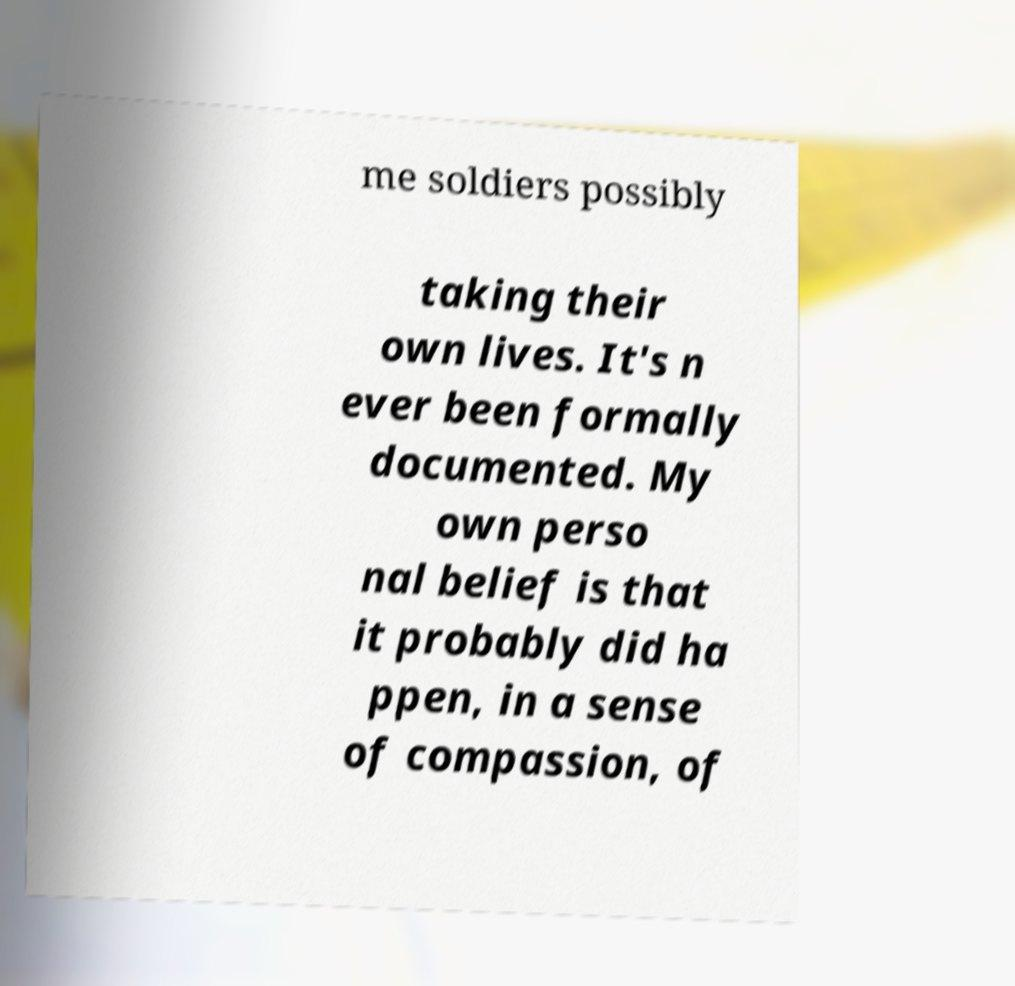Please identify and transcribe the text found in this image. me soldiers possibly taking their own lives. It's n ever been formally documented. My own perso nal belief is that it probably did ha ppen, in a sense of compassion, of 